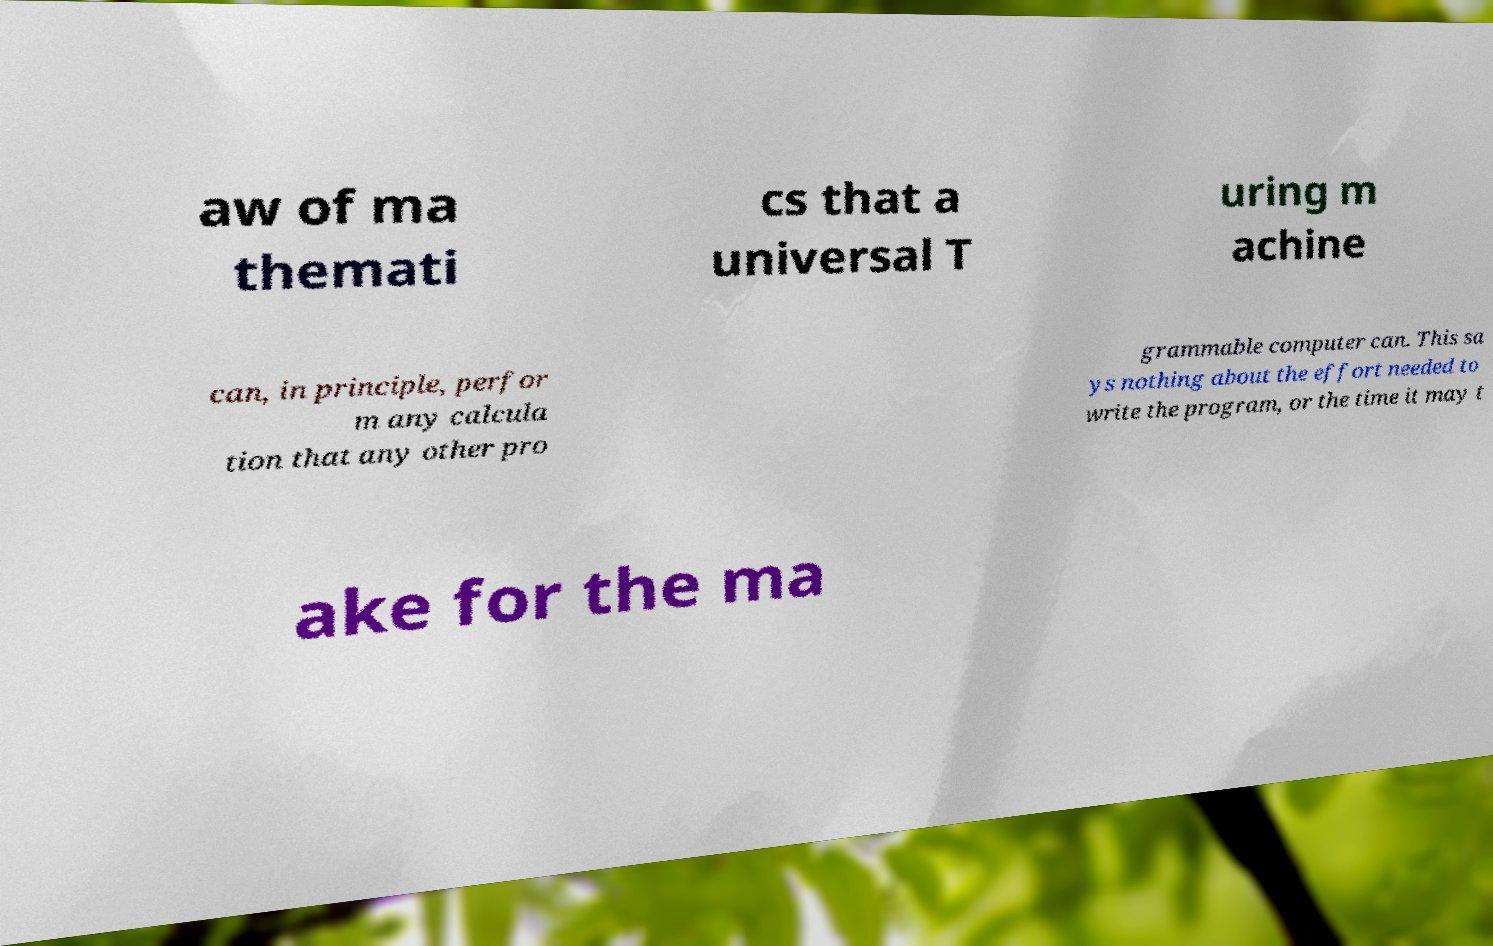There's text embedded in this image that I need extracted. Can you transcribe it verbatim? aw of ma themati cs that a universal T uring m achine can, in principle, perfor m any calcula tion that any other pro grammable computer can. This sa ys nothing about the effort needed to write the program, or the time it may t ake for the ma 